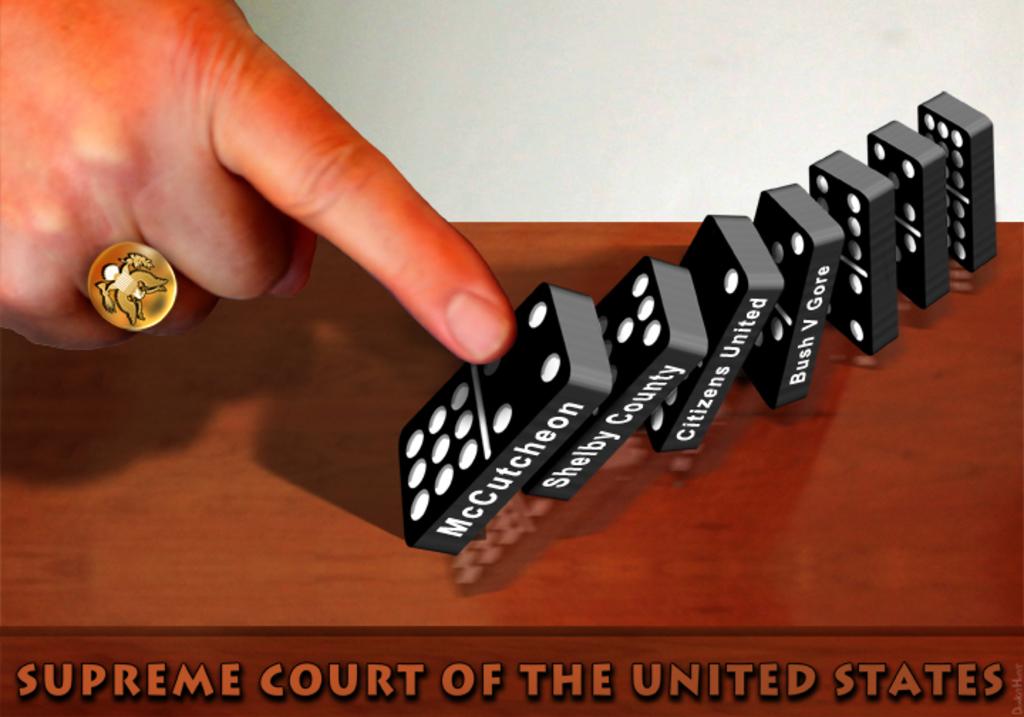What is written on the bottom of the image?
Make the answer very short. Supreme court of the united states. 